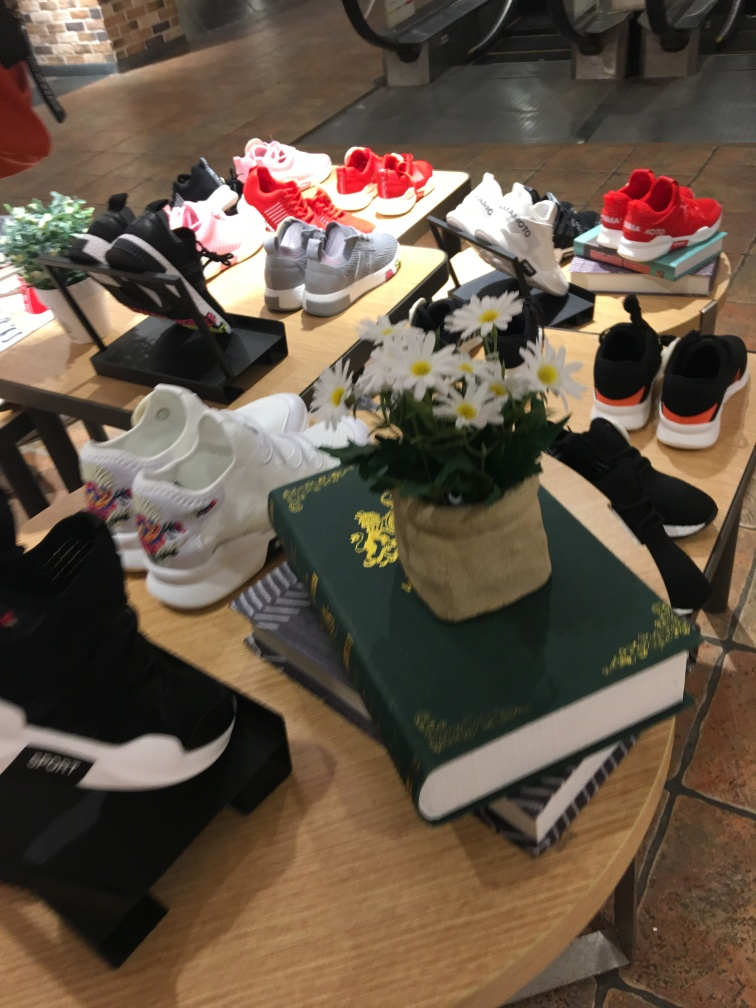Can you describe the lighting and mood of this image? The lighting in the image is soft and diffuse, likely from overhead sources common in retail spaces, which creates a welcoming and calm shopping atmosphere. The focus is on the products, and the light doesn’t overpower the scene but instead highlights the textures and colors of the shoes. 